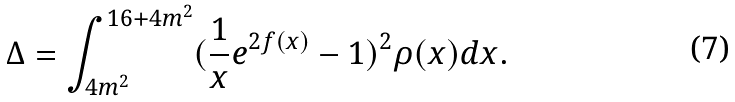<formula> <loc_0><loc_0><loc_500><loc_500>\Delta = \int ^ { 1 6 + 4 m ^ { 2 } } _ { 4 m ^ { 2 } } ( \frac { 1 } { x } e ^ { 2 f ( x ) } - 1 ) ^ { 2 } \rho ( x ) d x .</formula> 